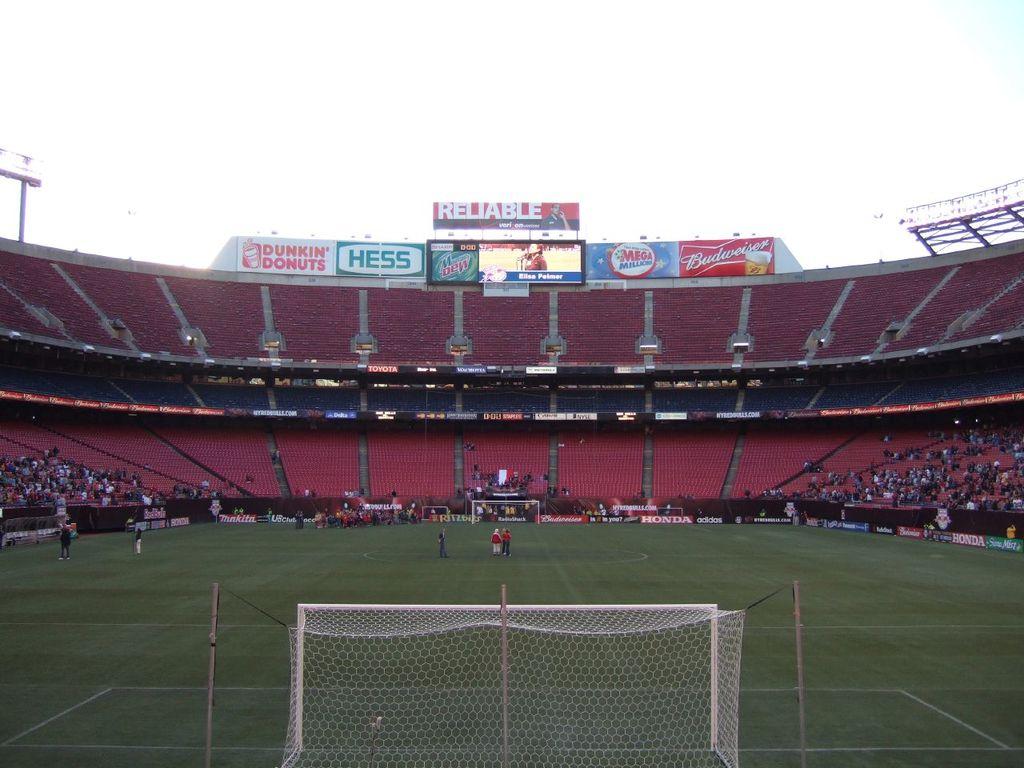Does dunkin donuts advertise here?
Provide a succinct answer. Yes. 